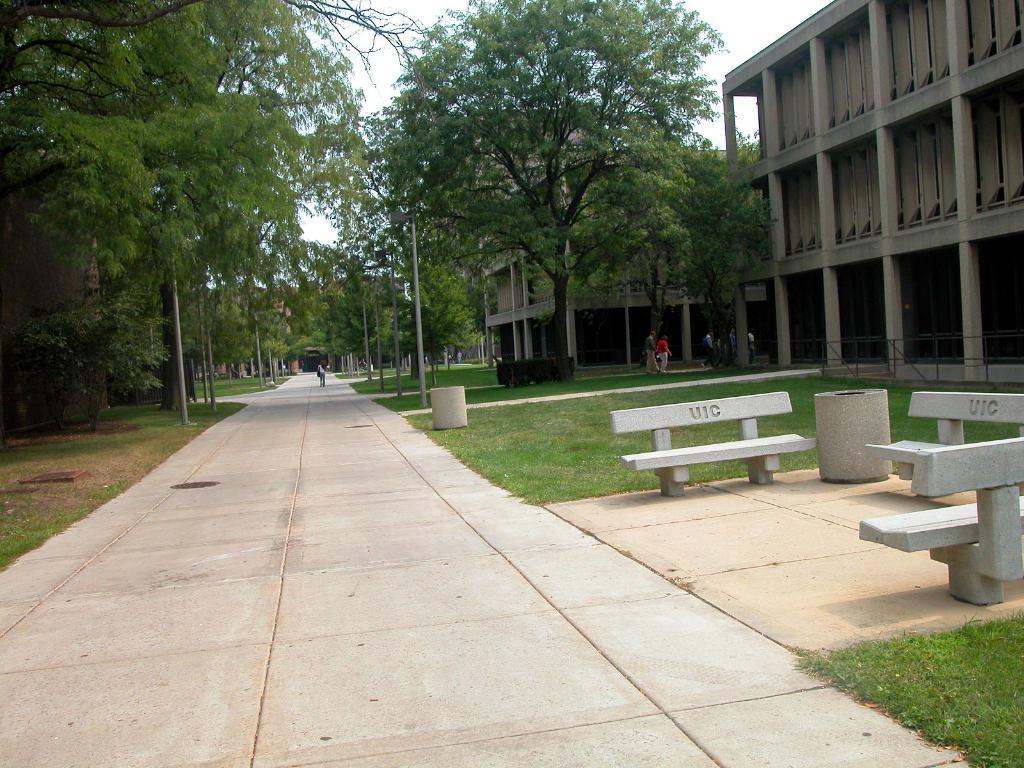Describe this image in one or two sentences. In this image, we can road where on the left side of the road, we can see chairs and some buildings and there are a few people on the road and there are some trees. On the right side of the road, the ground is covered with grass and there are trees which are green in color and there are poles too. 